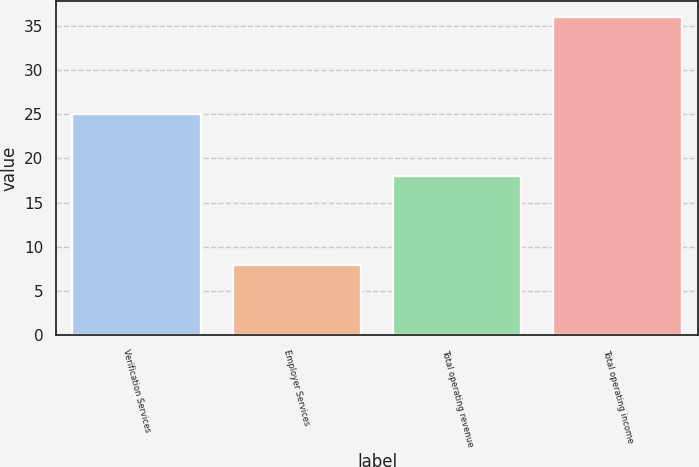Convert chart. <chart><loc_0><loc_0><loc_500><loc_500><bar_chart><fcel>Verification Services<fcel>Employer Services<fcel>Total operating revenue<fcel>Total operating income<nl><fcel>25<fcel>8<fcel>18<fcel>36<nl></chart> 